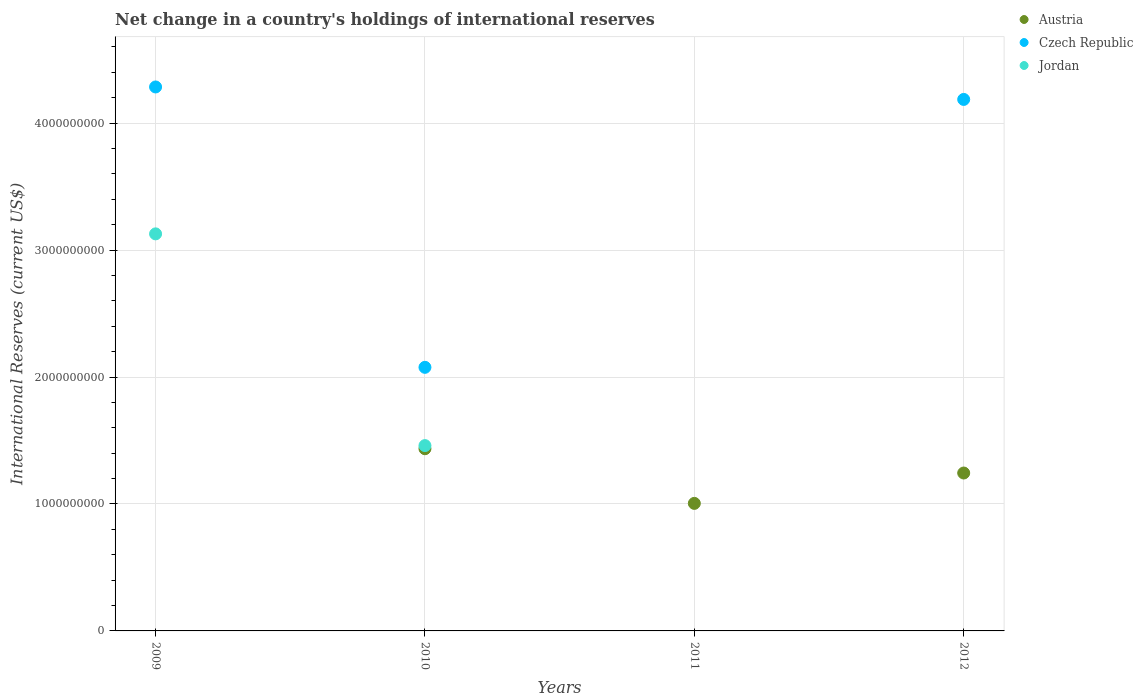What is the international reserves in Austria in 2012?
Provide a short and direct response. 1.24e+09. Across all years, what is the maximum international reserves in Jordan?
Give a very brief answer. 3.13e+09. In which year was the international reserves in Austria maximum?
Keep it short and to the point. 2010. What is the total international reserves in Czech Republic in the graph?
Provide a short and direct response. 1.05e+1. What is the difference between the international reserves in Jordan in 2009 and that in 2010?
Keep it short and to the point. 1.67e+09. What is the difference between the international reserves in Jordan in 2011 and the international reserves in Austria in 2012?
Your response must be concise. -1.24e+09. What is the average international reserves in Czech Republic per year?
Your answer should be compact. 2.64e+09. In the year 2010, what is the difference between the international reserves in Austria and international reserves in Czech Republic?
Give a very brief answer. -6.41e+08. What is the ratio of the international reserves in Austria in 2010 to that in 2011?
Your response must be concise. 1.43. What is the difference between the highest and the second highest international reserves in Czech Republic?
Your response must be concise. 9.81e+07. What is the difference between the highest and the lowest international reserves in Austria?
Give a very brief answer. 1.44e+09. Is the sum of the international reserves in Jordan in 2009 and 2010 greater than the maximum international reserves in Czech Republic across all years?
Offer a very short reply. Yes. Is the international reserves in Austria strictly greater than the international reserves in Czech Republic over the years?
Provide a succinct answer. No. Is the international reserves in Austria strictly less than the international reserves in Czech Republic over the years?
Offer a terse response. No. How many dotlines are there?
Ensure brevity in your answer.  3. How many years are there in the graph?
Your answer should be very brief. 4. What is the difference between two consecutive major ticks on the Y-axis?
Your answer should be compact. 1.00e+09. Does the graph contain any zero values?
Provide a short and direct response. Yes. Where does the legend appear in the graph?
Give a very brief answer. Top right. What is the title of the graph?
Offer a very short reply. Net change in a country's holdings of international reserves. What is the label or title of the Y-axis?
Offer a terse response. International Reserves (current US$). What is the International Reserves (current US$) of Austria in 2009?
Keep it short and to the point. 0. What is the International Reserves (current US$) in Czech Republic in 2009?
Provide a succinct answer. 4.28e+09. What is the International Reserves (current US$) of Jordan in 2009?
Offer a terse response. 3.13e+09. What is the International Reserves (current US$) in Austria in 2010?
Give a very brief answer. 1.44e+09. What is the International Reserves (current US$) of Czech Republic in 2010?
Your answer should be very brief. 2.08e+09. What is the International Reserves (current US$) in Jordan in 2010?
Keep it short and to the point. 1.46e+09. What is the International Reserves (current US$) in Austria in 2011?
Provide a short and direct response. 1.00e+09. What is the International Reserves (current US$) in Czech Republic in 2011?
Provide a succinct answer. 0. What is the International Reserves (current US$) of Austria in 2012?
Offer a very short reply. 1.24e+09. What is the International Reserves (current US$) in Czech Republic in 2012?
Give a very brief answer. 4.19e+09. Across all years, what is the maximum International Reserves (current US$) of Austria?
Provide a succinct answer. 1.44e+09. Across all years, what is the maximum International Reserves (current US$) in Czech Republic?
Provide a succinct answer. 4.28e+09. Across all years, what is the maximum International Reserves (current US$) of Jordan?
Provide a succinct answer. 3.13e+09. Across all years, what is the minimum International Reserves (current US$) in Austria?
Your response must be concise. 0. What is the total International Reserves (current US$) of Austria in the graph?
Give a very brief answer. 3.68e+09. What is the total International Reserves (current US$) of Czech Republic in the graph?
Ensure brevity in your answer.  1.05e+1. What is the total International Reserves (current US$) in Jordan in the graph?
Ensure brevity in your answer.  4.59e+09. What is the difference between the International Reserves (current US$) of Czech Republic in 2009 and that in 2010?
Your response must be concise. 2.21e+09. What is the difference between the International Reserves (current US$) of Jordan in 2009 and that in 2010?
Your answer should be compact. 1.67e+09. What is the difference between the International Reserves (current US$) of Czech Republic in 2009 and that in 2012?
Your response must be concise. 9.81e+07. What is the difference between the International Reserves (current US$) of Austria in 2010 and that in 2011?
Offer a terse response. 4.30e+08. What is the difference between the International Reserves (current US$) of Austria in 2010 and that in 2012?
Provide a succinct answer. 1.91e+08. What is the difference between the International Reserves (current US$) of Czech Republic in 2010 and that in 2012?
Make the answer very short. -2.11e+09. What is the difference between the International Reserves (current US$) in Austria in 2011 and that in 2012?
Provide a succinct answer. -2.39e+08. What is the difference between the International Reserves (current US$) in Czech Republic in 2009 and the International Reserves (current US$) in Jordan in 2010?
Provide a short and direct response. 2.82e+09. What is the difference between the International Reserves (current US$) of Austria in 2010 and the International Reserves (current US$) of Czech Republic in 2012?
Offer a very short reply. -2.75e+09. What is the difference between the International Reserves (current US$) of Austria in 2011 and the International Reserves (current US$) of Czech Republic in 2012?
Provide a succinct answer. -3.18e+09. What is the average International Reserves (current US$) in Austria per year?
Your answer should be compact. 9.21e+08. What is the average International Reserves (current US$) of Czech Republic per year?
Ensure brevity in your answer.  2.64e+09. What is the average International Reserves (current US$) in Jordan per year?
Offer a terse response. 1.15e+09. In the year 2009, what is the difference between the International Reserves (current US$) of Czech Republic and International Reserves (current US$) of Jordan?
Offer a very short reply. 1.16e+09. In the year 2010, what is the difference between the International Reserves (current US$) of Austria and International Reserves (current US$) of Czech Republic?
Provide a succinct answer. -6.41e+08. In the year 2010, what is the difference between the International Reserves (current US$) of Austria and International Reserves (current US$) of Jordan?
Give a very brief answer. -2.47e+07. In the year 2010, what is the difference between the International Reserves (current US$) in Czech Republic and International Reserves (current US$) in Jordan?
Give a very brief answer. 6.16e+08. In the year 2012, what is the difference between the International Reserves (current US$) of Austria and International Reserves (current US$) of Czech Republic?
Provide a succinct answer. -2.94e+09. What is the ratio of the International Reserves (current US$) of Czech Republic in 2009 to that in 2010?
Your answer should be very brief. 2.06. What is the ratio of the International Reserves (current US$) in Jordan in 2009 to that in 2010?
Ensure brevity in your answer.  2.14. What is the ratio of the International Reserves (current US$) of Czech Republic in 2009 to that in 2012?
Provide a succinct answer. 1.02. What is the ratio of the International Reserves (current US$) in Austria in 2010 to that in 2011?
Give a very brief answer. 1.43. What is the ratio of the International Reserves (current US$) in Austria in 2010 to that in 2012?
Provide a short and direct response. 1.15. What is the ratio of the International Reserves (current US$) of Czech Republic in 2010 to that in 2012?
Ensure brevity in your answer.  0.5. What is the ratio of the International Reserves (current US$) in Austria in 2011 to that in 2012?
Offer a very short reply. 0.81. What is the difference between the highest and the second highest International Reserves (current US$) in Austria?
Offer a terse response. 1.91e+08. What is the difference between the highest and the second highest International Reserves (current US$) in Czech Republic?
Make the answer very short. 9.81e+07. What is the difference between the highest and the lowest International Reserves (current US$) of Austria?
Ensure brevity in your answer.  1.44e+09. What is the difference between the highest and the lowest International Reserves (current US$) of Czech Republic?
Ensure brevity in your answer.  4.28e+09. What is the difference between the highest and the lowest International Reserves (current US$) in Jordan?
Your answer should be compact. 3.13e+09. 